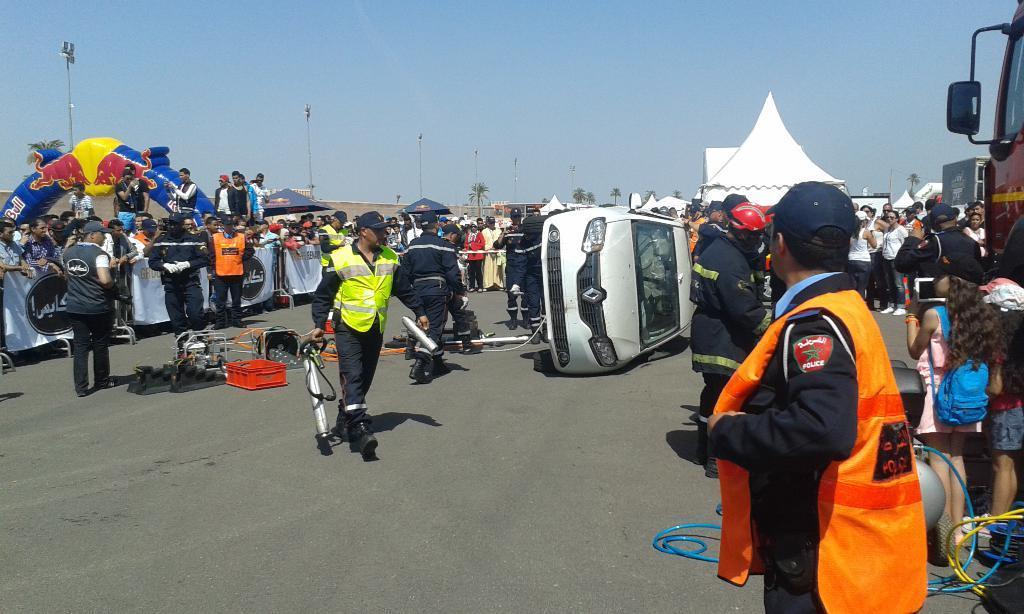In one or two sentences, can you explain what this image depicts? In this picture we can see a few people, vehicles and some objects on the road. There are canopy tents, an inflatable arch, trees, poles, banners, barricades, other objects and the sky. 